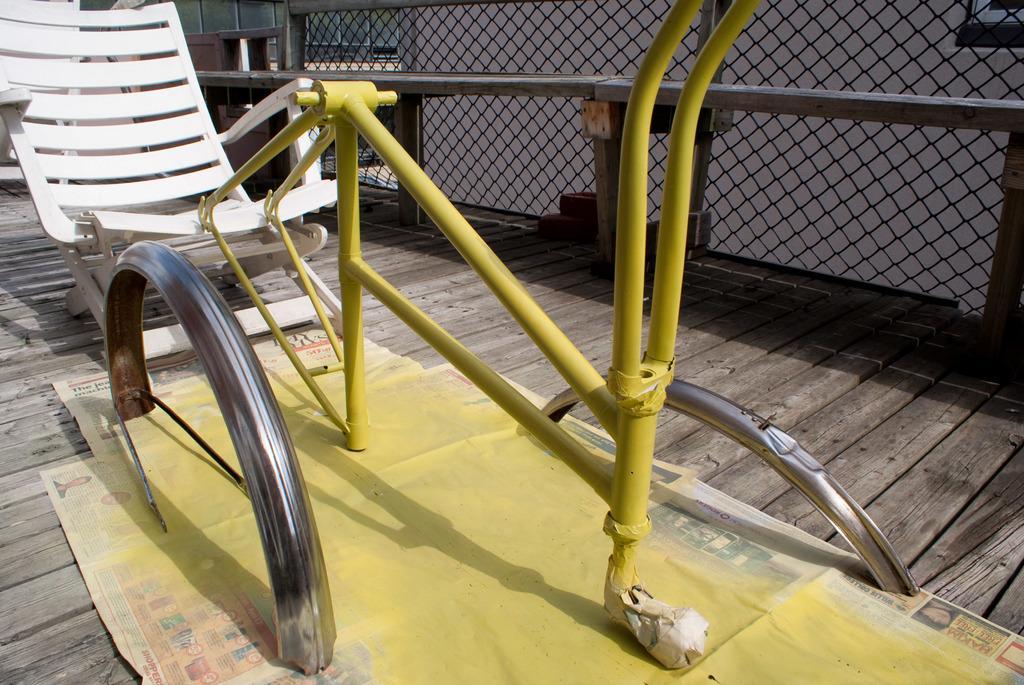Describe this image in one or two sentences. On the left side of the image we can see chair on the floor. In the background we can see fencing and building. 